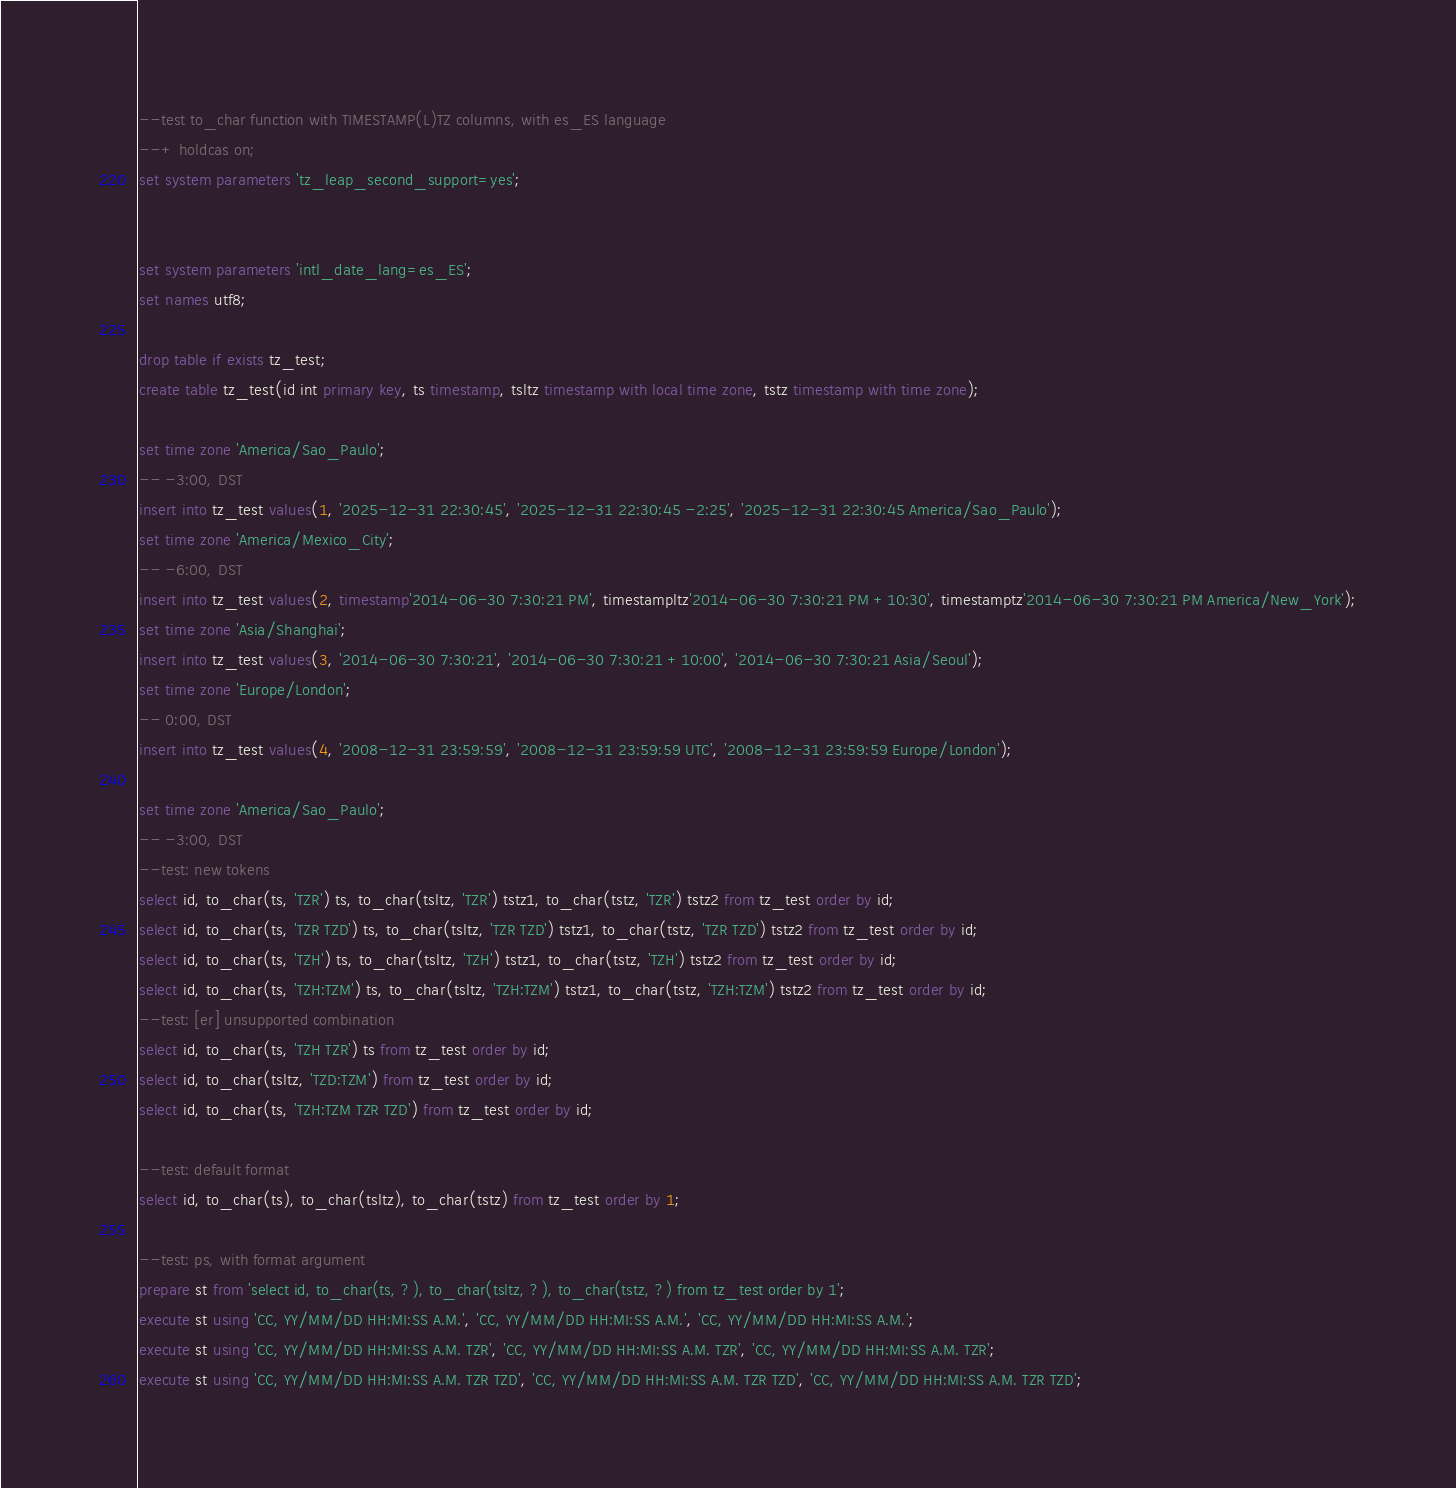<code> <loc_0><loc_0><loc_500><loc_500><_SQL_>--test to_char function with TIMESTAMP(L)TZ columns, with es_ES language
--+ holdcas on;
set system parameters 'tz_leap_second_support=yes';


set system parameters 'intl_date_lang=es_ES';
set names utf8;

drop table if exists tz_test;
create table tz_test(id int primary key, ts timestamp, tsltz timestamp with local time zone, tstz timestamp with time zone);

set time zone 'America/Sao_Paulo';
-- -3:00, DST
insert into tz_test values(1, '2025-12-31 22:30:45', '2025-12-31 22:30:45 -2:25', '2025-12-31 22:30:45 America/Sao_Paulo');
set time zone 'America/Mexico_City';
-- -6:00, DST
insert into tz_test values(2, timestamp'2014-06-30 7:30:21 PM', timestampltz'2014-06-30 7:30:21 PM +10:30', timestamptz'2014-06-30 7:30:21 PM America/New_York');
set time zone 'Asia/Shanghai';
insert into tz_test values(3, '2014-06-30 7:30:21', '2014-06-30 7:30:21 +10:00', '2014-06-30 7:30:21 Asia/Seoul');
set time zone 'Europe/London';
-- 0:00, DST
insert into tz_test values(4, '2008-12-31 23:59:59', '2008-12-31 23:59:59 UTC', '2008-12-31 23:59:59 Europe/London');

set time zone 'America/Sao_Paulo';
-- -3:00, DST
--test: new tokens
select id, to_char(ts, 'TZR') ts, to_char(tsltz, 'TZR') tstz1, to_char(tstz, 'TZR') tstz2 from tz_test order by id;
select id, to_char(ts, 'TZR TZD') ts, to_char(tsltz, 'TZR TZD') tstz1, to_char(tstz, 'TZR TZD') tstz2 from tz_test order by id;
select id, to_char(ts, 'TZH') ts, to_char(tsltz, 'TZH') tstz1, to_char(tstz, 'TZH') tstz2 from tz_test order by id;
select id, to_char(ts, 'TZH:TZM') ts, to_char(tsltz, 'TZH:TZM') tstz1, to_char(tstz, 'TZH:TZM') tstz2 from tz_test order by id;
--test: [er] unsupported combination
select id, to_char(ts, 'TZH TZR') ts from tz_test order by id;
select id, to_char(tsltz, 'TZD:TZM') from tz_test order by id;
select id, to_char(ts, 'TZH:TZM TZR TZD') from tz_test order by id;

--test: default format
select id, to_char(ts), to_char(tsltz), to_char(tstz) from tz_test order by 1;

--test: ps, with format argument
prepare st from 'select id, to_char(ts, ?), to_char(tsltz, ?), to_char(tstz, ?) from tz_test order by 1';
execute st using 'CC, YY/MM/DD HH:MI:SS A.M.', 'CC, YY/MM/DD HH:MI:SS A.M.', 'CC, YY/MM/DD HH:MI:SS A.M.';
execute st using 'CC, YY/MM/DD HH:MI:SS A.M. TZR', 'CC, YY/MM/DD HH:MI:SS A.M. TZR', 'CC, YY/MM/DD HH:MI:SS A.M. TZR';
execute st using 'CC, YY/MM/DD HH:MI:SS A.M. TZR TZD', 'CC, YY/MM/DD HH:MI:SS A.M. TZR TZD', 'CC, YY/MM/DD HH:MI:SS A.M. TZR TZD';</code> 